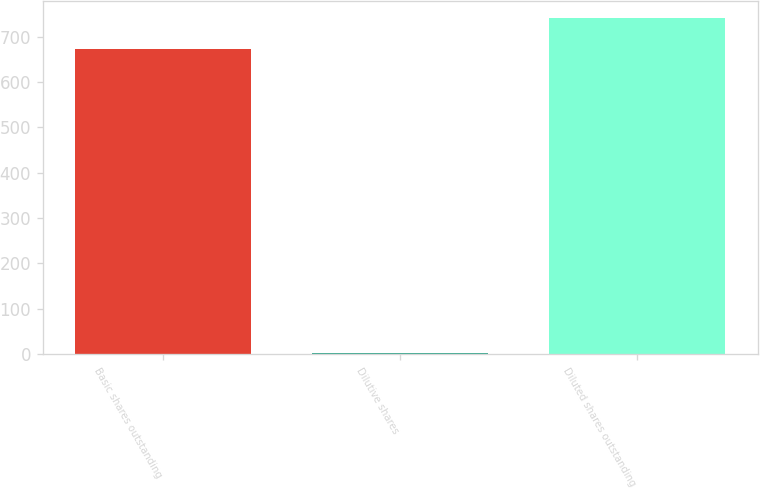<chart> <loc_0><loc_0><loc_500><loc_500><bar_chart><fcel>Basic shares outstanding<fcel>Dilutive shares<fcel>Diluted shares outstanding<nl><fcel>673.3<fcel>3.2<fcel>740.63<nl></chart> 